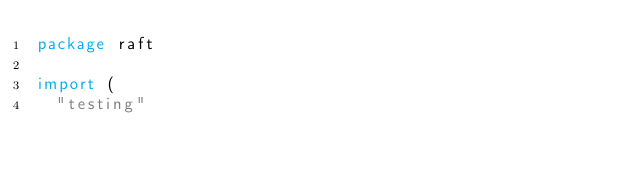<code> <loc_0><loc_0><loc_500><loc_500><_Go_>package raft

import (
	"testing"
</code> 